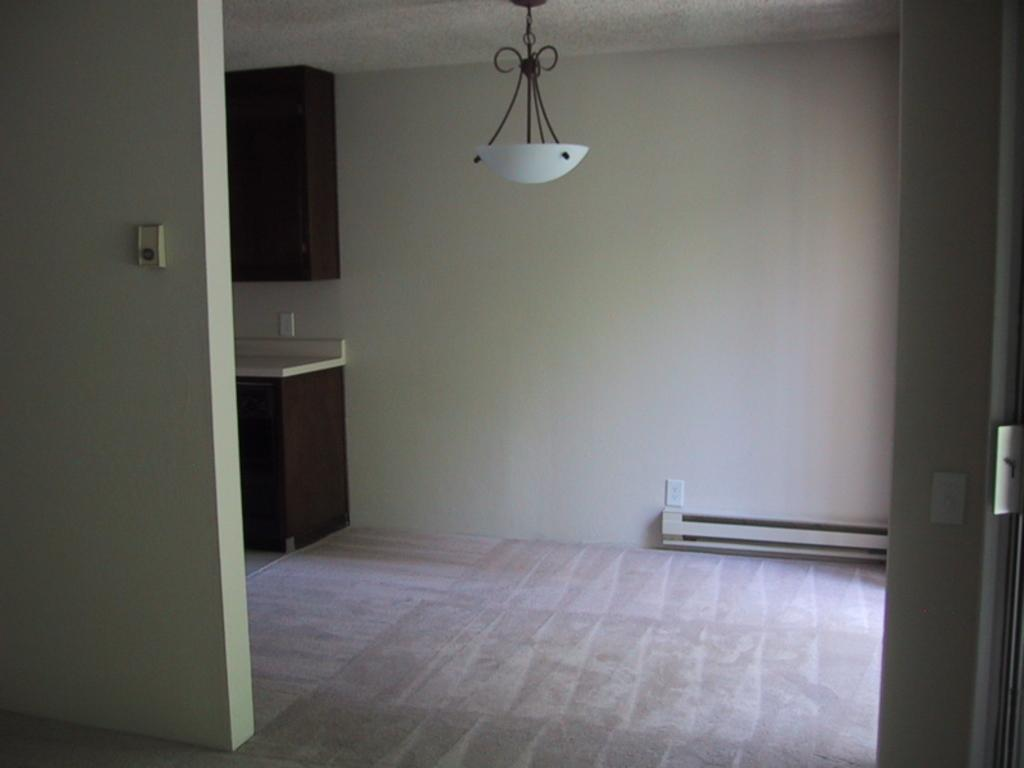What type of light source is visible in the image? There is an electric light in the image. What type of furniture is present in the image? There is a cabinet and a cupboard in the image. What type of structure is visible in the image? Walls are present in the image. Can you see any worms crawling on the walls in the image? There are no worms present in the image; it only features an electric light, a cabinet, a cupboard, and walls. What type of material is used to make the quilt on the cupboard in the image? There is no quilt present in the image; it only features an electric light, a cabinet, a cupboard, and walls. 